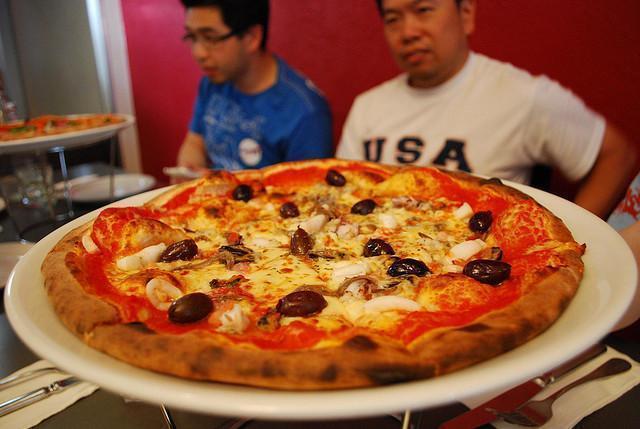What country does the shirt on the right mention?
Answer the question by selecting the correct answer among the 4 following choices.
Options: China, usa, japan, germany. Usa. 